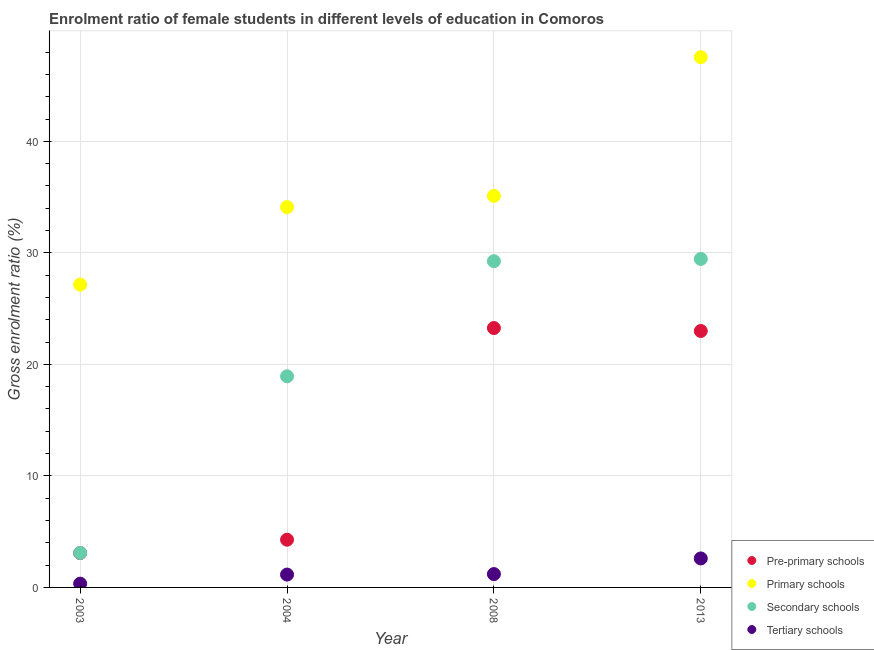How many different coloured dotlines are there?
Provide a succinct answer. 4. What is the gross enrolment ratio(male) in pre-primary schools in 2008?
Offer a terse response. 23.26. Across all years, what is the maximum gross enrolment ratio(male) in tertiary schools?
Provide a short and direct response. 2.6. Across all years, what is the minimum gross enrolment ratio(male) in pre-primary schools?
Make the answer very short. 3.08. In which year was the gross enrolment ratio(male) in tertiary schools maximum?
Keep it short and to the point. 2013. What is the total gross enrolment ratio(male) in secondary schools in the graph?
Give a very brief answer. 80.73. What is the difference between the gross enrolment ratio(male) in tertiary schools in 2004 and that in 2013?
Offer a terse response. -1.45. What is the difference between the gross enrolment ratio(male) in secondary schools in 2013 and the gross enrolment ratio(male) in pre-primary schools in 2004?
Offer a very short reply. 25.17. What is the average gross enrolment ratio(male) in pre-primary schools per year?
Your response must be concise. 13.4. In the year 2013, what is the difference between the gross enrolment ratio(male) in tertiary schools and gross enrolment ratio(male) in primary schools?
Provide a short and direct response. -44.95. In how many years, is the gross enrolment ratio(male) in secondary schools greater than 18 %?
Keep it short and to the point. 3. What is the ratio of the gross enrolment ratio(male) in pre-primary schools in 2004 to that in 2008?
Give a very brief answer. 0.18. What is the difference between the highest and the second highest gross enrolment ratio(male) in primary schools?
Offer a very short reply. 12.44. What is the difference between the highest and the lowest gross enrolment ratio(male) in pre-primary schools?
Ensure brevity in your answer.  20.18. In how many years, is the gross enrolment ratio(male) in tertiary schools greater than the average gross enrolment ratio(male) in tertiary schools taken over all years?
Keep it short and to the point. 1. How many dotlines are there?
Ensure brevity in your answer.  4. How many years are there in the graph?
Offer a very short reply. 4. Are the values on the major ticks of Y-axis written in scientific E-notation?
Ensure brevity in your answer.  No. Where does the legend appear in the graph?
Offer a very short reply. Bottom right. What is the title of the graph?
Your answer should be very brief. Enrolment ratio of female students in different levels of education in Comoros. Does "Denmark" appear as one of the legend labels in the graph?
Provide a succinct answer. No. What is the label or title of the Y-axis?
Make the answer very short. Gross enrolment ratio (%). What is the Gross enrolment ratio (%) in Pre-primary schools in 2003?
Offer a very short reply. 3.08. What is the Gross enrolment ratio (%) in Primary schools in 2003?
Make the answer very short. 27.15. What is the Gross enrolment ratio (%) of Secondary schools in 2003?
Provide a succinct answer. 3.09. What is the Gross enrolment ratio (%) in Tertiary schools in 2003?
Offer a very short reply. 0.34. What is the Gross enrolment ratio (%) of Pre-primary schools in 2004?
Your response must be concise. 4.28. What is the Gross enrolment ratio (%) of Primary schools in 2004?
Ensure brevity in your answer.  34.1. What is the Gross enrolment ratio (%) in Secondary schools in 2004?
Provide a short and direct response. 18.93. What is the Gross enrolment ratio (%) in Tertiary schools in 2004?
Your response must be concise. 1.15. What is the Gross enrolment ratio (%) in Pre-primary schools in 2008?
Your response must be concise. 23.26. What is the Gross enrolment ratio (%) of Primary schools in 2008?
Offer a very short reply. 35.11. What is the Gross enrolment ratio (%) in Secondary schools in 2008?
Your answer should be compact. 29.25. What is the Gross enrolment ratio (%) in Tertiary schools in 2008?
Offer a very short reply. 1.2. What is the Gross enrolment ratio (%) of Pre-primary schools in 2013?
Make the answer very short. 22.99. What is the Gross enrolment ratio (%) of Primary schools in 2013?
Offer a very short reply. 47.55. What is the Gross enrolment ratio (%) in Secondary schools in 2013?
Your answer should be very brief. 29.45. What is the Gross enrolment ratio (%) of Tertiary schools in 2013?
Offer a terse response. 2.6. Across all years, what is the maximum Gross enrolment ratio (%) in Pre-primary schools?
Provide a short and direct response. 23.26. Across all years, what is the maximum Gross enrolment ratio (%) in Primary schools?
Ensure brevity in your answer.  47.55. Across all years, what is the maximum Gross enrolment ratio (%) of Secondary schools?
Your response must be concise. 29.45. Across all years, what is the maximum Gross enrolment ratio (%) in Tertiary schools?
Your response must be concise. 2.6. Across all years, what is the minimum Gross enrolment ratio (%) of Pre-primary schools?
Ensure brevity in your answer.  3.08. Across all years, what is the minimum Gross enrolment ratio (%) of Primary schools?
Your answer should be compact. 27.15. Across all years, what is the minimum Gross enrolment ratio (%) in Secondary schools?
Provide a short and direct response. 3.09. Across all years, what is the minimum Gross enrolment ratio (%) in Tertiary schools?
Offer a very short reply. 0.34. What is the total Gross enrolment ratio (%) of Pre-primary schools in the graph?
Offer a terse response. 53.61. What is the total Gross enrolment ratio (%) in Primary schools in the graph?
Your answer should be very brief. 143.91. What is the total Gross enrolment ratio (%) in Secondary schools in the graph?
Your response must be concise. 80.73. What is the total Gross enrolment ratio (%) in Tertiary schools in the graph?
Keep it short and to the point. 5.29. What is the difference between the Gross enrolment ratio (%) of Pre-primary schools in 2003 and that in 2004?
Keep it short and to the point. -1.2. What is the difference between the Gross enrolment ratio (%) of Primary schools in 2003 and that in 2004?
Ensure brevity in your answer.  -6.95. What is the difference between the Gross enrolment ratio (%) of Secondary schools in 2003 and that in 2004?
Your response must be concise. -15.84. What is the difference between the Gross enrolment ratio (%) in Tertiary schools in 2003 and that in 2004?
Keep it short and to the point. -0.81. What is the difference between the Gross enrolment ratio (%) in Pre-primary schools in 2003 and that in 2008?
Offer a terse response. -20.18. What is the difference between the Gross enrolment ratio (%) of Primary schools in 2003 and that in 2008?
Your response must be concise. -7.96. What is the difference between the Gross enrolment ratio (%) of Secondary schools in 2003 and that in 2008?
Provide a succinct answer. -26.16. What is the difference between the Gross enrolment ratio (%) of Tertiary schools in 2003 and that in 2008?
Offer a very short reply. -0.86. What is the difference between the Gross enrolment ratio (%) of Pre-primary schools in 2003 and that in 2013?
Give a very brief answer. -19.91. What is the difference between the Gross enrolment ratio (%) in Primary schools in 2003 and that in 2013?
Keep it short and to the point. -20.4. What is the difference between the Gross enrolment ratio (%) in Secondary schools in 2003 and that in 2013?
Give a very brief answer. -26.36. What is the difference between the Gross enrolment ratio (%) in Tertiary schools in 2003 and that in 2013?
Make the answer very short. -2.26. What is the difference between the Gross enrolment ratio (%) of Pre-primary schools in 2004 and that in 2008?
Provide a succinct answer. -18.98. What is the difference between the Gross enrolment ratio (%) of Primary schools in 2004 and that in 2008?
Provide a short and direct response. -1.01. What is the difference between the Gross enrolment ratio (%) in Secondary schools in 2004 and that in 2008?
Provide a short and direct response. -10.32. What is the difference between the Gross enrolment ratio (%) in Tertiary schools in 2004 and that in 2008?
Make the answer very short. -0.04. What is the difference between the Gross enrolment ratio (%) in Pre-primary schools in 2004 and that in 2013?
Ensure brevity in your answer.  -18.71. What is the difference between the Gross enrolment ratio (%) of Primary schools in 2004 and that in 2013?
Keep it short and to the point. -13.45. What is the difference between the Gross enrolment ratio (%) of Secondary schools in 2004 and that in 2013?
Offer a terse response. -10.52. What is the difference between the Gross enrolment ratio (%) of Tertiary schools in 2004 and that in 2013?
Offer a very short reply. -1.45. What is the difference between the Gross enrolment ratio (%) of Pre-primary schools in 2008 and that in 2013?
Your response must be concise. 0.27. What is the difference between the Gross enrolment ratio (%) in Primary schools in 2008 and that in 2013?
Offer a terse response. -12.44. What is the difference between the Gross enrolment ratio (%) in Secondary schools in 2008 and that in 2013?
Ensure brevity in your answer.  -0.2. What is the difference between the Gross enrolment ratio (%) in Tertiary schools in 2008 and that in 2013?
Your answer should be compact. -1.4. What is the difference between the Gross enrolment ratio (%) in Pre-primary schools in 2003 and the Gross enrolment ratio (%) in Primary schools in 2004?
Provide a succinct answer. -31.02. What is the difference between the Gross enrolment ratio (%) in Pre-primary schools in 2003 and the Gross enrolment ratio (%) in Secondary schools in 2004?
Your answer should be compact. -15.85. What is the difference between the Gross enrolment ratio (%) of Pre-primary schools in 2003 and the Gross enrolment ratio (%) of Tertiary schools in 2004?
Your response must be concise. 1.93. What is the difference between the Gross enrolment ratio (%) in Primary schools in 2003 and the Gross enrolment ratio (%) in Secondary schools in 2004?
Your response must be concise. 8.22. What is the difference between the Gross enrolment ratio (%) in Primary schools in 2003 and the Gross enrolment ratio (%) in Tertiary schools in 2004?
Provide a succinct answer. 26. What is the difference between the Gross enrolment ratio (%) in Secondary schools in 2003 and the Gross enrolment ratio (%) in Tertiary schools in 2004?
Your answer should be compact. 1.94. What is the difference between the Gross enrolment ratio (%) in Pre-primary schools in 2003 and the Gross enrolment ratio (%) in Primary schools in 2008?
Ensure brevity in your answer.  -32.03. What is the difference between the Gross enrolment ratio (%) in Pre-primary schools in 2003 and the Gross enrolment ratio (%) in Secondary schools in 2008?
Your response must be concise. -26.17. What is the difference between the Gross enrolment ratio (%) of Pre-primary schools in 2003 and the Gross enrolment ratio (%) of Tertiary schools in 2008?
Keep it short and to the point. 1.88. What is the difference between the Gross enrolment ratio (%) in Primary schools in 2003 and the Gross enrolment ratio (%) in Secondary schools in 2008?
Your answer should be compact. -2.1. What is the difference between the Gross enrolment ratio (%) in Primary schools in 2003 and the Gross enrolment ratio (%) in Tertiary schools in 2008?
Your answer should be very brief. 25.96. What is the difference between the Gross enrolment ratio (%) of Secondary schools in 2003 and the Gross enrolment ratio (%) of Tertiary schools in 2008?
Ensure brevity in your answer.  1.9. What is the difference between the Gross enrolment ratio (%) in Pre-primary schools in 2003 and the Gross enrolment ratio (%) in Primary schools in 2013?
Provide a short and direct response. -44.47. What is the difference between the Gross enrolment ratio (%) in Pre-primary schools in 2003 and the Gross enrolment ratio (%) in Secondary schools in 2013?
Provide a succinct answer. -26.38. What is the difference between the Gross enrolment ratio (%) in Pre-primary schools in 2003 and the Gross enrolment ratio (%) in Tertiary schools in 2013?
Provide a succinct answer. 0.48. What is the difference between the Gross enrolment ratio (%) in Primary schools in 2003 and the Gross enrolment ratio (%) in Secondary schools in 2013?
Your answer should be very brief. -2.3. What is the difference between the Gross enrolment ratio (%) in Primary schools in 2003 and the Gross enrolment ratio (%) in Tertiary schools in 2013?
Ensure brevity in your answer.  24.55. What is the difference between the Gross enrolment ratio (%) of Secondary schools in 2003 and the Gross enrolment ratio (%) of Tertiary schools in 2013?
Your response must be concise. 0.49. What is the difference between the Gross enrolment ratio (%) in Pre-primary schools in 2004 and the Gross enrolment ratio (%) in Primary schools in 2008?
Your answer should be compact. -30.83. What is the difference between the Gross enrolment ratio (%) of Pre-primary schools in 2004 and the Gross enrolment ratio (%) of Secondary schools in 2008?
Make the answer very short. -24.97. What is the difference between the Gross enrolment ratio (%) in Pre-primary schools in 2004 and the Gross enrolment ratio (%) in Tertiary schools in 2008?
Offer a very short reply. 3.08. What is the difference between the Gross enrolment ratio (%) in Primary schools in 2004 and the Gross enrolment ratio (%) in Secondary schools in 2008?
Your response must be concise. 4.85. What is the difference between the Gross enrolment ratio (%) in Primary schools in 2004 and the Gross enrolment ratio (%) in Tertiary schools in 2008?
Keep it short and to the point. 32.9. What is the difference between the Gross enrolment ratio (%) in Secondary schools in 2004 and the Gross enrolment ratio (%) in Tertiary schools in 2008?
Offer a terse response. 17.73. What is the difference between the Gross enrolment ratio (%) in Pre-primary schools in 2004 and the Gross enrolment ratio (%) in Primary schools in 2013?
Your answer should be very brief. -43.27. What is the difference between the Gross enrolment ratio (%) in Pre-primary schools in 2004 and the Gross enrolment ratio (%) in Secondary schools in 2013?
Provide a succinct answer. -25.17. What is the difference between the Gross enrolment ratio (%) of Pre-primary schools in 2004 and the Gross enrolment ratio (%) of Tertiary schools in 2013?
Make the answer very short. 1.68. What is the difference between the Gross enrolment ratio (%) in Primary schools in 2004 and the Gross enrolment ratio (%) in Secondary schools in 2013?
Keep it short and to the point. 4.64. What is the difference between the Gross enrolment ratio (%) in Primary schools in 2004 and the Gross enrolment ratio (%) in Tertiary schools in 2013?
Keep it short and to the point. 31.5. What is the difference between the Gross enrolment ratio (%) of Secondary schools in 2004 and the Gross enrolment ratio (%) of Tertiary schools in 2013?
Give a very brief answer. 16.33. What is the difference between the Gross enrolment ratio (%) in Pre-primary schools in 2008 and the Gross enrolment ratio (%) in Primary schools in 2013?
Provide a short and direct response. -24.29. What is the difference between the Gross enrolment ratio (%) in Pre-primary schools in 2008 and the Gross enrolment ratio (%) in Secondary schools in 2013?
Your answer should be very brief. -6.2. What is the difference between the Gross enrolment ratio (%) of Pre-primary schools in 2008 and the Gross enrolment ratio (%) of Tertiary schools in 2013?
Offer a very short reply. 20.66. What is the difference between the Gross enrolment ratio (%) of Primary schools in 2008 and the Gross enrolment ratio (%) of Secondary schools in 2013?
Your answer should be compact. 5.66. What is the difference between the Gross enrolment ratio (%) of Primary schools in 2008 and the Gross enrolment ratio (%) of Tertiary schools in 2013?
Provide a short and direct response. 32.51. What is the difference between the Gross enrolment ratio (%) of Secondary schools in 2008 and the Gross enrolment ratio (%) of Tertiary schools in 2013?
Ensure brevity in your answer.  26.65. What is the average Gross enrolment ratio (%) in Pre-primary schools per year?
Your answer should be compact. 13.4. What is the average Gross enrolment ratio (%) of Primary schools per year?
Provide a succinct answer. 35.98. What is the average Gross enrolment ratio (%) in Secondary schools per year?
Keep it short and to the point. 20.18. What is the average Gross enrolment ratio (%) in Tertiary schools per year?
Provide a short and direct response. 1.32. In the year 2003, what is the difference between the Gross enrolment ratio (%) of Pre-primary schools and Gross enrolment ratio (%) of Primary schools?
Offer a terse response. -24.07. In the year 2003, what is the difference between the Gross enrolment ratio (%) of Pre-primary schools and Gross enrolment ratio (%) of Secondary schools?
Provide a short and direct response. -0.01. In the year 2003, what is the difference between the Gross enrolment ratio (%) of Pre-primary schools and Gross enrolment ratio (%) of Tertiary schools?
Give a very brief answer. 2.74. In the year 2003, what is the difference between the Gross enrolment ratio (%) of Primary schools and Gross enrolment ratio (%) of Secondary schools?
Keep it short and to the point. 24.06. In the year 2003, what is the difference between the Gross enrolment ratio (%) of Primary schools and Gross enrolment ratio (%) of Tertiary schools?
Keep it short and to the point. 26.81. In the year 2003, what is the difference between the Gross enrolment ratio (%) of Secondary schools and Gross enrolment ratio (%) of Tertiary schools?
Ensure brevity in your answer.  2.75. In the year 2004, what is the difference between the Gross enrolment ratio (%) of Pre-primary schools and Gross enrolment ratio (%) of Primary schools?
Offer a terse response. -29.82. In the year 2004, what is the difference between the Gross enrolment ratio (%) of Pre-primary schools and Gross enrolment ratio (%) of Secondary schools?
Provide a short and direct response. -14.65. In the year 2004, what is the difference between the Gross enrolment ratio (%) in Pre-primary schools and Gross enrolment ratio (%) in Tertiary schools?
Offer a very short reply. 3.13. In the year 2004, what is the difference between the Gross enrolment ratio (%) in Primary schools and Gross enrolment ratio (%) in Secondary schools?
Your answer should be compact. 15.17. In the year 2004, what is the difference between the Gross enrolment ratio (%) in Primary schools and Gross enrolment ratio (%) in Tertiary schools?
Your answer should be very brief. 32.95. In the year 2004, what is the difference between the Gross enrolment ratio (%) of Secondary schools and Gross enrolment ratio (%) of Tertiary schools?
Keep it short and to the point. 17.78. In the year 2008, what is the difference between the Gross enrolment ratio (%) of Pre-primary schools and Gross enrolment ratio (%) of Primary schools?
Ensure brevity in your answer.  -11.85. In the year 2008, what is the difference between the Gross enrolment ratio (%) of Pre-primary schools and Gross enrolment ratio (%) of Secondary schools?
Keep it short and to the point. -5.99. In the year 2008, what is the difference between the Gross enrolment ratio (%) of Pre-primary schools and Gross enrolment ratio (%) of Tertiary schools?
Make the answer very short. 22.06. In the year 2008, what is the difference between the Gross enrolment ratio (%) in Primary schools and Gross enrolment ratio (%) in Secondary schools?
Offer a very short reply. 5.86. In the year 2008, what is the difference between the Gross enrolment ratio (%) of Primary schools and Gross enrolment ratio (%) of Tertiary schools?
Provide a short and direct response. 33.91. In the year 2008, what is the difference between the Gross enrolment ratio (%) of Secondary schools and Gross enrolment ratio (%) of Tertiary schools?
Give a very brief answer. 28.05. In the year 2013, what is the difference between the Gross enrolment ratio (%) in Pre-primary schools and Gross enrolment ratio (%) in Primary schools?
Make the answer very short. -24.55. In the year 2013, what is the difference between the Gross enrolment ratio (%) of Pre-primary schools and Gross enrolment ratio (%) of Secondary schools?
Your answer should be very brief. -6.46. In the year 2013, what is the difference between the Gross enrolment ratio (%) of Pre-primary schools and Gross enrolment ratio (%) of Tertiary schools?
Offer a terse response. 20.39. In the year 2013, what is the difference between the Gross enrolment ratio (%) of Primary schools and Gross enrolment ratio (%) of Secondary schools?
Your answer should be very brief. 18.09. In the year 2013, what is the difference between the Gross enrolment ratio (%) of Primary schools and Gross enrolment ratio (%) of Tertiary schools?
Your answer should be compact. 44.95. In the year 2013, what is the difference between the Gross enrolment ratio (%) of Secondary schools and Gross enrolment ratio (%) of Tertiary schools?
Make the answer very short. 26.85. What is the ratio of the Gross enrolment ratio (%) of Pre-primary schools in 2003 to that in 2004?
Your response must be concise. 0.72. What is the ratio of the Gross enrolment ratio (%) of Primary schools in 2003 to that in 2004?
Offer a terse response. 0.8. What is the ratio of the Gross enrolment ratio (%) in Secondary schools in 2003 to that in 2004?
Offer a very short reply. 0.16. What is the ratio of the Gross enrolment ratio (%) of Tertiary schools in 2003 to that in 2004?
Ensure brevity in your answer.  0.29. What is the ratio of the Gross enrolment ratio (%) in Pre-primary schools in 2003 to that in 2008?
Offer a terse response. 0.13. What is the ratio of the Gross enrolment ratio (%) of Primary schools in 2003 to that in 2008?
Keep it short and to the point. 0.77. What is the ratio of the Gross enrolment ratio (%) of Secondary schools in 2003 to that in 2008?
Offer a terse response. 0.11. What is the ratio of the Gross enrolment ratio (%) in Tertiary schools in 2003 to that in 2008?
Provide a succinct answer. 0.28. What is the ratio of the Gross enrolment ratio (%) in Pre-primary schools in 2003 to that in 2013?
Give a very brief answer. 0.13. What is the ratio of the Gross enrolment ratio (%) of Primary schools in 2003 to that in 2013?
Your answer should be compact. 0.57. What is the ratio of the Gross enrolment ratio (%) of Secondary schools in 2003 to that in 2013?
Offer a very short reply. 0.1. What is the ratio of the Gross enrolment ratio (%) in Tertiary schools in 2003 to that in 2013?
Ensure brevity in your answer.  0.13. What is the ratio of the Gross enrolment ratio (%) in Pre-primary schools in 2004 to that in 2008?
Provide a short and direct response. 0.18. What is the ratio of the Gross enrolment ratio (%) in Primary schools in 2004 to that in 2008?
Give a very brief answer. 0.97. What is the ratio of the Gross enrolment ratio (%) in Secondary schools in 2004 to that in 2008?
Keep it short and to the point. 0.65. What is the ratio of the Gross enrolment ratio (%) in Tertiary schools in 2004 to that in 2008?
Give a very brief answer. 0.96. What is the ratio of the Gross enrolment ratio (%) of Pre-primary schools in 2004 to that in 2013?
Provide a short and direct response. 0.19. What is the ratio of the Gross enrolment ratio (%) in Primary schools in 2004 to that in 2013?
Provide a short and direct response. 0.72. What is the ratio of the Gross enrolment ratio (%) of Secondary schools in 2004 to that in 2013?
Provide a succinct answer. 0.64. What is the ratio of the Gross enrolment ratio (%) in Tertiary schools in 2004 to that in 2013?
Your answer should be compact. 0.44. What is the ratio of the Gross enrolment ratio (%) in Pre-primary schools in 2008 to that in 2013?
Your answer should be very brief. 1.01. What is the ratio of the Gross enrolment ratio (%) of Primary schools in 2008 to that in 2013?
Ensure brevity in your answer.  0.74. What is the ratio of the Gross enrolment ratio (%) in Tertiary schools in 2008 to that in 2013?
Your answer should be very brief. 0.46. What is the difference between the highest and the second highest Gross enrolment ratio (%) of Pre-primary schools?
Make the answer very short. 0.27. What is the difference between the highest and the second highest Gross enrolment ratio (%) of Primary schools?
Offer a terse response. 12.44. What is the difference between the highest and the second highest Gross enrolment ratio (%) in Secondary schools?
Ensure brevity in your answer.  0.2. What is the difference between the highest and the second highest Gross enrolment ratio (%) in Tertiary schools?
Provide a succinct answer. 1.4. What is the difference between the highest and the lowest Gross enrolment ratio (%) of Pre-primary schools?
Offer a very short reply. 20.18. What is the difference between the highest and the lowest Gross enrolment ratio (%) of Primary schools?
Your answer should be very brief. 20.4. What is the difference between the highest and the lowest Gross enrolment ratio (%) in Secondary schools?
Give a very brief answer. 26.36. What is the difference between the highest and the lowest Gross enrolment ratio (%) of Tertiary schools?
Your answer should be very brief. 2.26. 